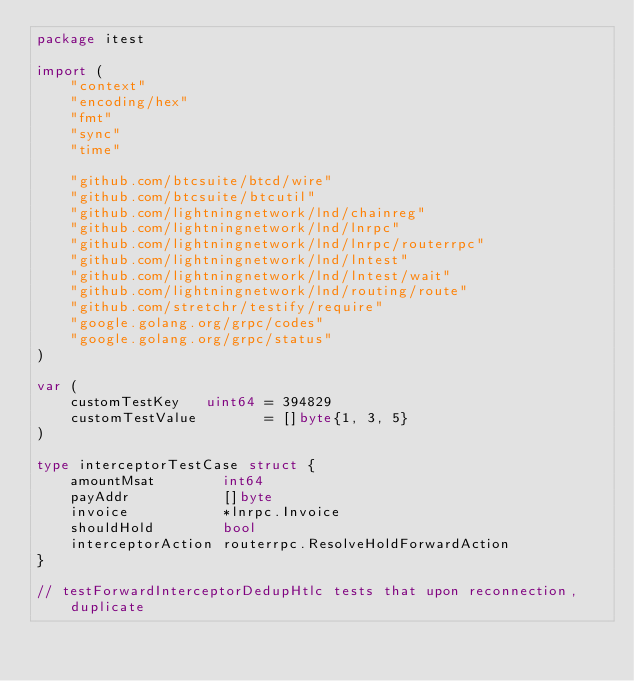Convert code to text. <code><loc_0><loc_0><loc_500><loc_500><_Go_>package itest

import (
	"context"
	"encoding/hex"
	"fmt"
	"sync"
	"time"

	"github.com/btcsuite/btcd/wire"
	"github.com/btcsuite/btcutil"
	"github.com/lightningnetwork/lnd/chainreg"
	"github.com/lightningnetwork/lnd/lnrpc"
	"github.com/lightningnetwork/lnd/lnrpc/routerrpc"
	"github.com/lightningnetwork/lnd/lntest"
	"github.com/lightningnetwork/lnd/lntest/wait"
	"github.com/lightningnetwork/lnd/routing/route"
	"github.com/stretchr/testify/require"
	"google.golang.org/grpc/codes"
	"google.golang.org/grpc/status"
)

var (
	customTestKey   uint64 = 394829
	customTestValue        = []byte{1, 3, 5}
)

type interceptorTestCase struct {
	amountMsat        int64
	payAddr           []byte
	invoice           *lnrpc.Invoice
	shouldHold        bool
	interceptorAction routerrpc.ResolveHoldForwardAction
}

// testForwardInterceptorDedupHtlc tests that upon reconnection, duplicate</code> 